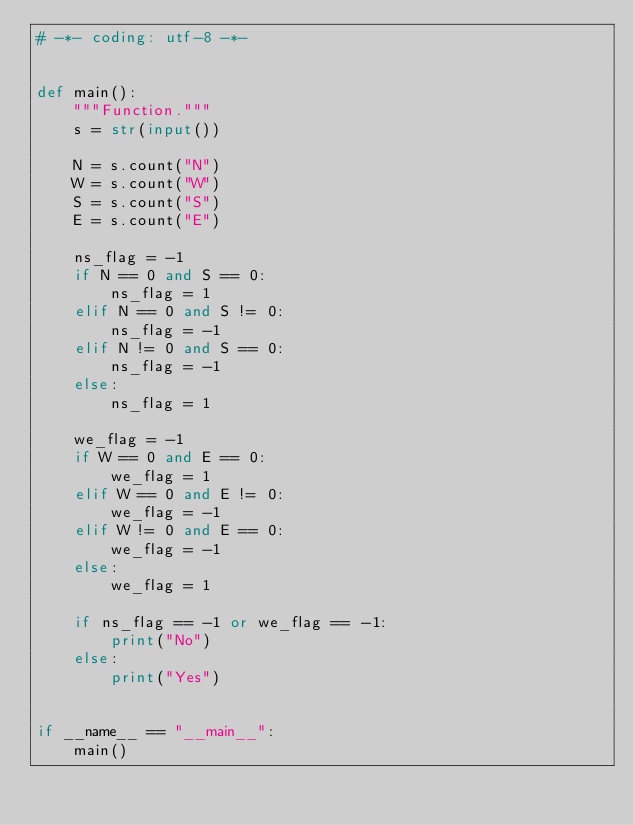<code> <loc_0><loc_0><loc_500><loc_500><_Python_># -*- coding: utf-8 -*-


def main():
    """Function."""
    s = str(input())

    N = s.count("N")
    W = s.count("W")
    S = s.count("S")
    E = s.count("E")

    ns_flag = -1
    if N == 0 and S == 0:
        ns_flag = 1
    elif N == 0 and S != 0:
        ns_flag = -1
    elif N != 0 and S == 0:
        ns_flag = -1
    else:
        ns_flag = 1

    we_flag = -1
    if W == 0 and E == 0:
        we_flag = 1
    elif W == 0 and E != 0:
        we_flag = -1
    elif W != 0 and E == 0:
        we_flag = -1
    else:
        we_flag = 1

    if ns_flag == -1 or we_flag == -1:
        print("No")
    else:
        print("Yes")


if __name__ == "__main__":
    main()
</code> 